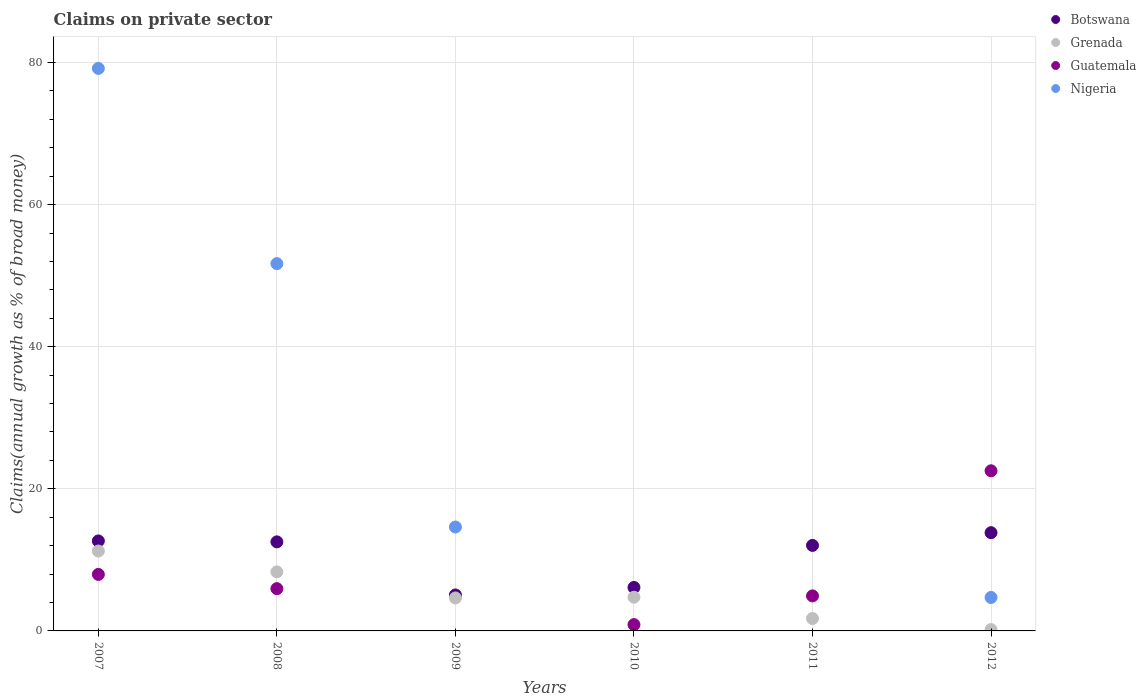What is the percentage of broad money claimed on private sector in Nigeria in 2008?
Your answer should be very brief. 51.69. Across all years, what is the maximum percentage of broad money claimed on private sector in Nigeria?
Provide a short and direct response. 79.17. Across all years, what is the minimum percentage of broad money claimed on private sector in Botswana?
Make the answer very short. 5.06. In which year was the percentage of broad money claimed on private sector in Guatemala maximum?
Offer a very short reply. 2012. What is the total percentage of broad money claimed on private sector in Botswana in the graph?
Ensure brevity in your answer.  62.25. What is the difference between the percentage of broad money claimed on private sector in Grenada in 2007 and that in 2008?
Your answer should be very brief. 2.93. What is the difference between the percentage of broad money claimed on private sector in Grenada in 2008 and the percentage of broad money claimed on private sector in Nigeria in 2012?
Give a very brief answer. 3.6. What is the average percentage of broad money claimed on private sector in Grenada per year?
Your response must be concise. 5.15. In the year 2010, what is the difference between the percentage of broad money claimed on private sector in Botswana and percentage of broad money claimed on private sector in Guatemala?
Your answer should be compact. 5.23. In how many years, is the percentage of broad money claimed on private sector in Guatemala greater than 44 %?
Ensure brevity in your answer.  0. What is the ratio of the percentage of broad money claimed on private sector in Guatemala in 2008 to that in 2012?
Offer a terse response. 0.26. Is the percentage of broad money claimed on private sector in Grenada in 2010 less than that in 2012?
Provide a short and direct response. No. What is the difference between the highest and the second highest percentage of broad money claimed on private sector in Guatemala?
Give a very brief answer. 14.58. What is the difference between the highest and the lowest percentage of broad money claimed on private sector in Guatemala?
Make the answer very short. 22.54. In how many years, is the percentage of broad money claimed on private sector in Guatemala greater than the average percentage of broad money claimed on private sector in Guatemala taken over all years?
Your answer should be very brief. 2. Is the sum of the percentage of broad money claimed on private sector in Botswana in 2011 and 2012 greater than the maximum percentage of broad money claimed on private sector in Grenada across all years?
Provide a succinct answer. Yes. Does the percentage of broad money claimed on private sector in Botswana monotonically increase over the years?
Your response must be concise. No. Is the percentage of broad money claimed on private sector in Grenada strictly less than the percentage of broad money claimed on private sector in Nigeria over the years?
Your response must be concise. No. How many years are there in the graph?
Provide a short and direct response. 6. What is the difference between two consecutive major ticks on the Y-axis?
Offer a terse response. 20. Are the values on the major ticks of Y-axis written in scientific E-notation?
Your response must be concise. No. What is the title of the graph?
Your response must be concise. Claims on private sector. What is the label or title of the X-axis?
Keep it short and to the point. Years. What is the label or title of the Y-axis?
Your answer should be compact. Claims(annual growth as % of broad money). What is the Claims(annual growth as % of broad money) in Botswana in 2007?
Provide a short and direct response. 12.67. What is the Claims(annual growth as % of broad money) of Grenada in 2007?
Your response must be concise. 11.25. What is the Claims(annual growth as % of broad money) of Guatemala in 2007?
Offer a very short reply. 7.96. What is the Claims(annual growth as % of broad money) of Nigeria in 2007?
Provide a short and direct response. 79.17. What is the Claims(annual growth as % of broad money) in Botswana in 2008?
Offer a very short reply. 12.54. What is the Claims(annual growth as % of broad money) of Grenada in 2008?
Your response must be concise. 8.31. What is the Claims(annual growth as % of broad money) in Guatemala in 2008?
Make the answer very short. 5.95. What is the Claims(annual growth as % of broad money) in Nigeria in 2008?
Give a very brief answer. 51.69. What is the Claims(annual growth as % of broad money) of Botswana in 2009?
Your answer should be compact. 5.06. What is the Claims(annual growth as % of broad money) of Grenada in 2009?
Ensure brevity in your answer.  4.64. What is the Claims(annual growth as % of broad money) in Nigeria in 2009?
Ensure brevity in your answer.  14.63. What is the Claims(annual growth as % of broad money) in Botswana in 2010?
Ensure brevity in your answer.  6.12. What is the Claims(annual growth as % of broad money) in Grenada in 2010?
Your answer should be compact. 4.75. What is the Claims(annual growth as % of broad money) of Guatemala in 2010?
Offer a terse response. 0.88. What is the Claims(annual growth as % of broad money) of Nigeria in 2010?
Keep it short and to the point. 0. What is the Claims(annual growth as % of broad money) of Botswana in 2011?
Provide a short and direct response. 12.04. What is the Claims(annual growth as % of broad money) in Grenada in 2011?
Ensure brevity in your answer.  1.75. What is the Claims(annual growth as % of broad money) of Guatemala in 2011?
Ensure brevity in your answer.  4.93. What is the Claims(annual growth as % of broad money) in Botswana in 2012?
Provide a succinct answer. 13.83. What is the Claims(annual growth as % of broad money) in Grenada in 2012?
Keep it short and to the point. 0.19. What is the Claims(annual growth as % of broad money) of Guatemala in 2012?
Your answer should be very brief. 22.54. What is the Claims(annual growth as % of broad money) of Nigeria in 2012?
Your response must be concise. 4.71. Across all years, what is the maximum Claims(annual growth as % of broad money) in Botswana?
Provide a short and direct response. 13.83. Across all years, what is the maximum Claims(annual growth as % of broad money) in Grenada?
Your answer should be very brief. 11.25. Across all years, what is the maximum Claims(annual growth as % of broad money) of Guatemala?
Give a very brief answer. 22.54. Across all years, what is the maximum Claims(annual growth as % of broad money) of Nigeria?
Offer a very short reply. 79.17. Across all years, what is the minimum Claims(annual growth as % of broad money) in Botswana?
Ensure brevity in your answer.  5.06. Across all years, what is the minimum Claims(annual growth as % of broad money) of Grenada?
Your answer should be very brief. 0.19. Across all years, what is the minimum Claims(annual growth as % of broad money) of Nigeria?
Give a very brief answer. 0. What is the total Claims(annual growth as % of broad money) in Botswana in the graph?
Make the answer very short. 62.25. What is the total Claims(annual growth as % of broad money) in Grenada in the graph?
Offer a terse response. 30.88. What is the total Claims(annual growth as % of broad money) in Guatemala in the graph?
Keep it short and to the point. 42.26. What is the total Claims(annual growth as % of broad money) of Nigeria in the graph?
Offer a very short reply. 150.2. What is the difference between the Claims(annual growth as % of broad money) of Botswana in 2007 and that in 2008?
Ensure brevity in your answer.  0.13. What is the difference between the Claims(annual growth as % of broad money) of Grenada in 2007 and that in 2008?
Ensure brevity in your answer.  2.93. What is the difference between the Claims(annual growth as % of broad money) in Guatemala in 2007 and that in 2008?
Give a very brief answer. 2.01. What is the difference between the Claims(annual growth as % of broad money) of Nigeria in 2007 and that in 2008?
Your answer should be very brief. 27.48. What is the difference between the Claims(annual growth as % of broad money) in Botswana in 2007 and that in 2009?
Ensure brevity in your answer.  7.61. What is the difference between the Claims(annual growth as % of broad money) of Grenada in 2007 and that in 2009?
Offer a very short reply. 6.6. What is the difference between the Claims(annual growth as % of broad money) in Nigeria in 2007 and that in 2009?
Keep it short and to the point. 64.55. What is the difference between the Claims(annual growth as % of broad money) of Botswana in 2007 and that in 2010?
Your answer should be very brief. 6.55. What is the difference between the Claims(annual growth as % of broad money) of Guatemala in 2007 and that in 2010?
Your response must be concise. 7.07. What is the difference between the Claims(annual growth as % of broad money) in Botswana in 2007 and that in 2011?
Offer a terse response. 0.63. What is the difference between the Claims(annual growth as % of broad money) of Grenada in 2007 and that in 2011?
Provide a succinct answer. 9.5. What is the difference between the Claims(annual growth as % of broad money) of Guatemala in 2007 and that in 2011?
Ensure brevity in your answer.  3.02. What is the difference between the Claims(annual growth as % of broad money) of Botswana in 2007 and that in 2012?
Offer a very short reply. -1.16. What is the difference between the Claims(annual growth as % of broad money) in Grenada in 2007 and that in 2012?
Provide a short and direct response. 11.06. What is the difference between the Claims(annual growth as % of broad money) in Guatemala in 2007 and that in 2012?
Offer a terse response. -14.58. What is the difference between the Claims(annual growth as % of broad money) in Nigeria in 2007 and that in 2012?
Your answer should be very brief. 74.47. What is the difference between the Claims(annual growth as % of broad money) in Botswana in 2008 and that in 2009?
Give a very brief answer. 7.47. What is the difference between the Claims(annual growth as % of broad money) of Grenada in 2008 and that in 2009?
Your response must be concise. 3.67. What is the difference between the Claims(annual growth as % of broad money) of Nigeria in 2008 and that in 2009?
Provide a short and direct response. 37.07. What is the difference between the Claims(annual growth as % of broad money) in Botswana in 2008 and that in 2010?
Give a very brief answer. 6.42. What is the difference between the Claims(annual growth as % of broad money) in Grenada in 2008 and that in 2010?
Ensure brevity in your answer.  3.57. What is the difference between the Claims(annual growth as % of broad money) in Guatemala in 2008 and that in 2010?
Give a very brief answer. 5.06. What is the difference between the Claims(annual growth as % of broad money) of Botswana in 2008 and that in 2011?
Make the answer very short. 0.5. What is the difference between the Claims(annual growth as % of broad money) in Grenada in 2008 and that in 2011?
Offer a very short reply. 6.56. What is the difference between the Claims(annual growth as % of broad money) in Guatemala in 2008 and that in 2011?
Give a very brief answer. 1.02. What is the difference between the Claims(annual growth as % of broad money) in Botswana in 2008 and that in 2012?
Keep it short and to the point. -1.29. What is the difference between the Claims(annual growth as % of broad money) of Grenada in 2008 and that in 2012?
Ensure brevity in your answer.  8.12. What is the difference between the Claims(annual growth as % of broad money) in Guatemala in 2008 and that in 2012?
Make the answer very short. -16.59. What is the difference between the Claims(annual growth as % of broad money) in Nigeria in 2008 and that in 2012?
Your answer should be compact. 46.99. What is the difference between the Claims(annual growth as % of broad money) of Botswana in 2009 and that in 2010?
Ensure brevity in your answer.  -1.06. What is the difference between the Claims(annual growth as % of broad money) of Grenada in 2009 and that in 2010?
Provide a short and direct response. -0.1. What is the difference between the Claims(annual growth as % of broad money) of Botswana in 2009 and that in 2011?
Make the answer very short. -6.97. What is the difference between the Claims(annual growth as % of broad money) of Grenada in 2009 and that in 2011?
Your answer should be compact. 2.9. What is the difference between the Claims(annual growth as % of broad money) in Botswana in 2009 and that in 2012?
Ensure brevity in your answer.  -8.77. What is the difference between the Claims(annual growth as % of broad money) in Grenada in 2009 and that in 2012?
Give a very brief answer. 4.45. What is the difference between the Claims(annual growth as % of broad money) in Nigeria in 2009 and that in 2012?
Offer a terse response. 9.92. What is the difference between the Claims(annual growth as % of broad money) of Botswana in 2010 and that in 2011?
Give a very brief answer. -5.92. What is the difference between the Claims(annual growth as % of broad money) in Grenada in 2010 and that in 2011?
Offer a terse response. 3. What is the difference between the Claims(annual growth as % of broad money) in Guatemala in 2010 and that in 2011?
Give a very brief answer. -4.05. What is the difference between the Claims(annual growth as % of broad money) in Botswana in 2010 and that in 2012?
Your response must be concise. -7.71. What is the difference between the Claims(annual growth as % of broad money) in Grenada in 2010 and that in 2012?
Your response must be concise. 4.56. What is the difference between the Claims(annual growth as % of broad money) in Guatemala in 2010 and that in 2012?
Your answer should be compact. -21.65. What is the difference between the Claims(annual growth as % of broad money) in Botswana in 2011 and that in 2012?
Your response must be concise. -1.79. What is the difference between the Claims(annual growth as % of broad money) of Grenada in 2011 and that in 2012?
Make the answer very short. 1.56. What is the difference between the Claims(annual growth as % of broad money) of Guatemala in 2011 and that in 2012?
Your response must be concise. -17.61. What is the difference between the Claims(annual growth as % of broad money) of Botswana in 2007 and the Claims(annual growth as % of broad money) of Grenada in 2008?
Provide a succinct answer. 4.36. What is the difference between the Claims(annual growth as % of broad money) of Botswana in 2007 and the Claims(annual growth as % of broad money) of Guatemala in 2008?
Your answer should be very brief. 6.72. What is the difference between the Claims(annual growth as % of broad money) in Botswana in 2007 and the Claims(annual growth as % of broad money) in Nigeria in 2008?
Offer a very short reply. -39.03. What is the difference between the Claims(annual growth as % of broad money) in Grenada in 2007 and the Claims(annual growth as % of broad money) in Guatemala in 2008?
Give a very brief answer. 5.3. What is the difference between the Claims(annual growth as % of broad money) in Grenada in 2007 and the Claims(annual growth as % of broad money) in Nigeria in 2008?
Make the answer very short. -40.45. What is the difference between the Claims(annual growth as % of broad money) in Guatemala in 2007 and the Claims(annual growth as % of broad money) in Nigeria in 2008?
Provide a succinct answer. -43.74. What is the difference between the Claims(annual growth as % of broad money) in Botswana in 2007 and the Claims(annual growth as % of broad money) in Grenada in 2009?
Make the answer very short. 8.03. What is the difference between the Claims(annual growth as % of broad money) of Botswana in 2007 and the Claims(annual growth as % of broad money) of Nigeria in 2009?
Give a very brief answer. -1.96. What is the difference between the Claims(annual growth as % of broad money) of Grenada in 2007 and the Claims(annual growth as % of broad money) of Nigeria in 2009?
Your answer should be compact. -3.38. What is the difference between the Claims(annual growth as % of broad money) of Guatemala in 2007 and the Claims(annual growth as % of broad money) of Nigeria in 2009?
Provide a succinct answer. -6.67. What is the difference between the Claims(annual growth as % of broad money) of Botswana in 2007 and the Claims(annual growth as % of broad money) of Grenada in 2010?
Your answer should be very brief. 7.92. What is the difference between the Claims(annual growth as % of broad money) of Botswana in 2007 and the Claims(annual growth as % of broad money) of Guatemala in 2010?
Provide a short and direct response. 11.78. What is the difference between the Claims(annual growth as % of broad money) in Grenada in 2007 and the Claims(annual growth as % of broad money) in Guatemala in 2010?
Offer a terse response. 10.36. What is the difference between the Claims(annual growth as % of broad money) of Botswana in 2007 and the Claims(annual growth as % of broad money) of Grenada in 2011?
Your response must be concise. 10.92. What is the difference between the Claims(annual growth as % of broad money) in Botswana in 2007 and the Claims(annual growth as % of broad money) in Guatemala in 2011?
Provide a short and direct response. 7.73. What is the difference between the Claims(annual growth as % of broad money) in Grenada in 2007 and the Claims(annual growth as % of broad money) in Guatemala in 2011?
Your answer should be compact. 6.31. What is the difference between the Claims(annual growth as % of broad money) in Botswana in 2007 and the Claims(annual growth as % of broad money) in Grenada in 2012?
Keep it short and to the point. 12.48. What is the difference between the Claims(annual growth as % of broad money) in Botswana in 2007 and the Claims(annual growth as % of broad money) in Guatemala in 2012?
Offer a very short reply. -9.87. What is the difference between the Claims(annual growth as % of broad money) of Botswana in 2007 and the Claims(annual growth as % of broad money) of Nigeria in 2012?
Keep it short and to the point. 7.96. What is the difference between the Claims(annual growth as % of broad money) of Grenada in 2007 and the Claims(annual growth as % of broad money) of Guatemala in 2012?
Offer a very short reply. -11.29. What is the difference between the Claims(annual growth as % of broad money) in Grenada in 2007 and the Claims(annual growth as % of broad money) in Nigeria in 2012?
Your answer should be compact. 6.54. What is the difference between the Claims(annual growth as % of broad money) in Guatemala in 2007 and the Claims(annual growth as % of broad money) in Nigeria in 2012?
Offer a very short reply. 3.25. What is the difference between the Claims(annual growth as % of broad money) of Botswana in 2008 and the Claims(annual growth as % of broad money) of Grenada in 2009?
Offer a very short reply. 7.89. What is the difference between the Claims(annual growth as % of broad money) in Botswana in 2008 and the Claims(annual growth as % of broad money) in Nigeria in 2009?
Provide a succinct answer. -2.09. What is the difference between the Claims(annual growth as % of broad money) of Grenada in 2008 and the Claims(annual growth as % of broad money) of Nigeria in 2009?
Give a very brief answer. -6.32. What is the difference between the Claims(annual growth as % of broad money) of Guatemala in 2008 and the Claims(annual growth as % of broad money) of Nigeria in 2009?
Ensure brevity in your answer.  -8.68. What is the difference between the Claims(annual growth as % of broad money) in Botswana in 2008 and the Claims(annual growth as % of broad money) in Grenada in 2010?
Your answer should be compact. 7.79. What is the difference between the Claims(annual growth as % of broad money) in Botswana in 2008 and the Claims(annual growth as % of broad money) in Guatemala in 2010?
Provide a short and direct response. 11.65. What is the difference between the Claims(annual growth as % of broad money) in Grenada in 2008 and the Claims(annual growth as % of broad money) in Guatemala in 2010?
Provide a short and direct response. 7.43. What is the difference between the Claims(annual growth as % of broad money) in Botswana in 2008 and the Claims(annual growth as % of broad money) in Grenada in 2011?
Your answer should be very brief. 10.79. What is the difference between the Claims(annual growth as % of broad money) of Botswana in 2008 and the Claims(annual growth as % of broad money) of Guatemala in 2011?
Give a very brief answer. 7.6. What is the difference between the Claims(annual growth as % of broad money) in Grenada in 2008 and the Claims(annual growth as % of broad money) in Guatemala in 2011?
Give a very brief answer. 3.38. What is the difference between the Claims(annual growth as % of broad money) in Botswana in 2008 and the Claims(annual growth as % of broad money) in Grenada in 2012?
Make the answer very short. 12.35. What is the difference between the Claims(annual growth as % of broad money) of Botswana in 2008 and the Claims(annual growth as % of broad money) of Guatemala in 2012?
Your response must be concise. -10. What is the difference between the Claims(annual growth as % of broad money) in Botswana in 2008 and the Claims(annual growth as % of broad money) in Nigeria in 2012?
Give a very brief answer. 7.83. What is the difference between the Claims(annual growth as % of broad money) of Grenada in 2008 and the Claims(annual growth as % of broad money) of Guatemala in 2012?
Your answer should be compact. -14.23. What is the difference between the Claims(annual growth as % of broad money) in Grenada in 2008 and the Claims(annual growth as % of broad money) in Nigeria in 2012?
Your answer should be compact. 3.6. What is the difference between the Claims(annual growth as % of broad money) in Guatemala in 2008 and the Claims(annual growth as % of broad money) in Nigeria in 2012?
Your answer should be very brief. 1.24. What is the difference between the Claims(annual growth as % of broad money) of Botswana in 2009 and the Claims(annual growth as % of broad money) of Grenada in 2010?
Provide a short and direct response. 0.32. What is the difference between the Claims(annual growth as % of broad money) of Botswana in 2009 and the Claims(annual growth as % of broad money) of Guatemala in 2010?
Give a very brief answer. 4.18. What is the difference between the Claims(annual growth as % of broad money) in Grenada in 2009 and the Claims(annual growth as % of broad money) in Guatemala in 2010?
Your answer should be very brief. 3.76. What is the difference between the Claims(annual growth as % of broad money) in Botswana in 2009 and the Claims(annual growth as % of broad money) in Grenada in 2011?
Your answer should be compact. 3.31. What is the difference between the Claims(annual growth as % of broad money) in Botswana in 2009 and the Claims(annual growth as % of broad money) in Guatemala in 2011?
Your answer should be compact. 0.13. What is the difference between the Claims(annual growth as % of broad money) of Grenada in 2009 and the Claims(annual growth as % of broad money) of Guatemala in 2011?
Keep it short and to the point. -0.29. What is the difference between the Claims(annual growth as % of broad money) of Botswana in 2009 and the Claims(annual growth as % of broad money) of Grenada in 2012?
Offer a terse response. 4.87. What is the difference between the Claims(annual growth as % of broad money) in Botswana in 2009 and the Claims(annual growth as % of broad money) in Guatemala in 2012?
Offer a terse response. -17.48. What is the difference between the Claims(annual growth as % of broad money) in Botswana in 2009 and the Claims(annual growth as % of broad money) in Nigeria in 2012?
Provide a short and direct response. 0.35. What is the difference between the Claims(annual growth as % of broad money) in Grenada in 2009 and the Claims(annual growth as % of broad money) in Guatemala in 2012?
Offer a very short reply. -17.9. What is the difference between the Claims(annual growth as % of broad money) in Grenada in 2009 and the Claims(annual growth as % of broad money) in Nigeria in 2012?
Ensure brevity in your answer.  -0.07. What is the difference between the Claims(annual growth as % of broad money) in Botswana in 2010 and the Claims(annual growth as % of broad money) in Grenada in 2011?
Offer a terse response. 4.37. What is the difference between the Claims(annual growth as % of broad money) in Botswana in 2010 and the Claims(annual growth as % of broad money) in Guatemala in 2011?
Give a very brief answer. 1.19. What is the difference between the Claims(annual growth as % of broad money) in Grenada in 2010 and the Claims(annual growth as % of broad money) in Guatemala in 2011?
Provide a short and direct response. -0.19. What is the difference between the Claims(annual growth as % of broad money) of Botswana in 2010 and the Claims(annual growth as % of broad money) of Grenada in 2012?
Your answer should be compact. 5.93. What is the difference between the Claims(annual growth as % of broad money) in Botswana in 2010 and the Claims(annual growth as % of broad money) in Guatemala in 2012?
Your answer should be compact. -16.42. What is the difference between the Claims(annual growth as % of broad money) of Botswana in 2010 and the Claims(annual growth as % of broad money) of Nigeria in 2012?
Offer a very short reply. 1.41. What is the difference between the Claims(annual growth as % of broad money) in Grenada in 2010 and the Claims(annual growth as % of broad money) in Guatemala in 2012?
Provide a succinct answer. -17.79. What is the difference between the Claims(annual growth as % of broad money) in Grenada in 2010 and the Claims(annual growth as % of broad money) in Nigeria in 2012?
Keep it short and to the point. 0.04. What is the difference between the Claims(annual growth as % of broad money) of Guatemala in 2010 and the Claims(annual growth as % of broad money) of Nigeria in 2012?
Your answer should be compact. -3.82. What is the difference between the Claims(annual growth as % of broad money) of Botswana in 2011 and the Claims(annual growth as % of broad money) of Grenada in 2012?
Give a very brief answer. 11.85. What is the difference between the Claims(annual growth as % of broad money) of Botswana in 2011 and the Claims(annual growth as % of broad money) of Guatemala in 2012?
Offer a terse response. -10.5. What is the difference between the Claims(annual growth as % of broad money) in Botswana in 2011 and the Claims(annual growth as % of broad money) in Nigeria in 2012?
Provide a succinct answer. 7.33. What is the difference between the Claims(annual growth as % of broad money) of Grenada in 2011 and the Claims(annual growth as % of broad money) of Guatemala in 2012?
Your response must be concise. -20.79. What is the difference between the Claims(annual growth as % of broad money) in Grenada in 2011 and the Claims(annual growth as % of broad money) in Nigeria in 2012?
Make the answer very short. -2.96. What is the difference between the Claims(annual growth as % of broad money) of Guatemala in 2011 and the Claims(annual growth as % of broad money) of Nigeria in 2012?
Your response must be concise. 0.22. What is the average Claims(annual growth as % of broad money) of Botswana per year?
Ensure brevity in your answer.  10.37. What is the average Claims(annual growth as % of broad money) in Grenada per year?
Ensure brevity in your answer.  5.15. What is the average Claims(annual growth as % of broad money) of Guatemala per year?
Keep it short and to the point. 7.04. What is the average Claims(annual growth as % of broad money) of Nigeria per year?
Provide a succinct answer. 25.03. In the year 2007, what is the difference between the Claims(annual growth as % of broad money) in Botswana and Claims(annual growth as % of broad money) in Grenada?
Offer a terse response. 1.42. In the year 2007, what is the difference between the Claims(annual growth as % of broad money) of Botswana and Claims(annual growth as % of broad money) of Guatemala?
Offer a very short reply. 4.71. In the year 2007, what is the difference between the Claims(annual growth as % of broad money) in Botswana and Claims(annual growth as % of broad money) in Nigeria?
Make the answer very short. -66.51. In the year 2007, what is the difference between the Claims(annual growth as % of broad money) in Grenada and Claims(annual growth as % of broad money) in Guatemala?
Your answer should be compact. 3.29. In the year 2007, what is the difference between the Claims(annual growth as % of broad money) in Grenada and Claims(annual growth as % of broad money) in Nigeria?
Your answer should be compact. -67.93. In the year 2007, what is the difference between the Claims(annual growth as % of broad money) in Guatemala and Claims(annual growth as % of broad money) in Nigeria?
Ensure brevity in your answer.  -71.22. In the year 2008, what is the difference between the Claims(annual growth as % of broad money) of Botswana and Claims(annual growth as % of broad money) of Grenada?
Your response must be concise. 4.23. In the year 2008, what is the difference between the Claims(annual growth as % of broad money) of Botswana and Claims(annual growth as % of broad money) of Guatemala?
Your answer should be compact. 6.59. In the year 2008, what is the difference between the Claims(annual growth as % of broad money) of Botswana and Claims(annual growth as % of broad money) of Nigeria?
Your answer should be compact. -39.16. In the year 2008, what is the difference between the Claims(annual growth as % of broad money) of Grenada and Claims(annual growth as % of broad money) of Guatemala?
Your answer should be compact. 2.36. In the year 2008, what is the difference between the Claims(annual growth as % of broad money) of Grenada and Claims(annual growth as % of broad money) of Nigeria?
Your answer should be compact. -43.38. In the year 2008, what is the difference between the Claims(annual growth as % of broad money) in Guatemala and Claims(annual growth as % of broad money) in Nigeria?
Ensure brevity in your answer.  -45.75. In the year 2009, what is the difference between the Claims(annual growth as % of broad money) in Botswana and Claims(annual growth as % of broad money) in Grenada?
Provide a succinct answer. 0.42. In the year 2009, what is the difference between the Claims(annual growth as % of broad money) of Botswana and Claims(annual growth as % of broad money) of Nigeria?
Your response must be concise. -9.57. In the year 2009, what is the difference between the Claims(annual growth as % of broad money) of Grenada and Claims(annual growth as % of broad money) of Nigeria?
Provide a short and direct response. -9.98. In the year 2010, what is the difference between the Claims(annual growth as % of broad money) of Botswana and Claims(annual growth as % of broad money) of Grenada?
Your response must be concise. 1.37. In the year 2010, what is the difference between the Claims(annual growth as % of broad money) of Botswana and Claims(annual growth as % of broad money) of Guatemala?
Make the answer very short. 5.23. In the year 2010, what is the difference between the Claims(annual growth as % of broad money) of Grenada and Claims(annual growth as % of broad money) of Guatemala?
Make the answer very short. 3.86. In the year 2011, what is the difference between the Claims(annual growth as % of broad money) in Botswana and Claims(annual growth as % of broad money) in Grenada?
Provide a succinct answer. 10.29. In the year 2011, what is the difference between the Claims(annual growth as % of broad money) of Botswana and Claims(annual growth as % of broad money) of Guatemala?
Offer a very short reply. 7.1. In the year 2011, what is the difference between the Claims(annual growth as % of broad money) in Grenada and Claims(annual growth as % of broad money) in Guatemala?
Ensure brevity in your answer.  -3.19. In the year 2012, what is the difference between the Claims(annual growth as % of broad money) of Botswana and Claims(annual growth as % of broad money) of Grenada?
Keep it short and to the point. 13.64. In the year 2012, what is the difference between the Claims(annual growth as % of broad money) in Botswana and Claims(annual growth as % of broad money) in Guatemala?
Give a very brief answer. -8.71. In the year 2012, what is the difference between the Claims(annual growth as % of broad money) of Botswana and Claims(annual growth as % of broad money) of Nigeria?
Keep it short and to the point. 9.12. In the year 2012, what is the difference between the Claims(annual growth as % of broad money) in Grenada and Claims(annual growth as % of broad money) in Guatemala?
Your response must be concise. -22.35. In the year 2012, what is the difference between the Claims(annual growth as % of broad money) in Grenada and Claims(annual growth as % of broad money) in Nigeria?
Offer a very short reply. -4.52. In the year 2012, what is the difference between the Claims(annual growth as % of broad money) of Guatemala and Claims(annual growth as % of broad money) of Nigeria?
Offer a terse response. 17.83. What is the ratio of the Claims(annual growth as % of broad money) in Botswana in 2007 to that in 2008?
Provide a short and direct response. 1.01. What is the ratio of the Claims(annual growth as % of broad money) of Grenada in 2007 to that in 2008?
Make the answer very short. 1.35. What is the ratio of the Claims(annual growth as % of broad money) of Guatemala in 2007 to that in 2008?
Give a very brief answer. 1.34. What is the ratio of the Claims(annual growth as % of broad money) in Nigeria in 2007 to that in 2008?
Offer a very short reply. 1.53. What is the ratio of the Claims(annual growth as % of broad money) in Botswana in 2007 to that in 2009?
Ensure brevity in your answer.  2.5. What is the ratio of the Claims(annual growth as % of broad money) of Grenada in 2007 to that in 2009?
Your response must be concise. 2.42. What is the ratio of the Claims(annual growth as % of broad money) in Nigeria in 2007 to that in 2009?
Provide a short and direct response. 5.41. What is the ratio of the Claims(annual growth as % of broad money) in Botswana in 2007 to that in 2010?
Ensure brevity in your answer.  2.07. What is the ratio of the Claims(annual growth as % of broad money) in Grenada in 2007 to that in 2010?
Make the answer very short. 2.37. What is the ratio of the Claims(annual growth as % of broad money) of Guatemala in 2007 to that in 2010?
Keep it short and to the point. 8.99. What is the ratio of the Claims(annual growth as % of broad money) of Botswana in 2007 to that in 2011?
Offer a very short reply. 1.05. What is the ratio of the Claims(annual growth as % of broad money) in Grenada in 2007 to that in 2011?
Make the answer very short. 6.44. What is the ratio of the Claims(annual growth as % of broad money) in Guatemala in 2007 to that in 2011?
Provide a succinct answer. 1.61. What is the ratio of the Claims(annual growth as % of broad money) in Botswana in 2007 to that in 2012?
Offer a very short reply. 0.92. What is the ratio of the Claims(annual growth as % of broad money) of Grenada in 2007 to that in 2012?
Provide a succinct answer. 59.76. What is the ratio of the Claims(annual growth as % of broad money) of Guatemala in 2007 to that in 2012?
Provide a succinct answer. 0.35. What is the ratio of the Claims(annual growth as % of broad money) of Nigeria in 2007 to that in 2012?
Offer a very short reply. 16.82. What is the ratio of the Claims(annual growth as % of broad money) in Botswana in 2008 to that in 2009?
Your answer should be very brief. 2.48. What is the ratio of the Claims(annual growth as % of broad money) of Grenada in 2008 to that in 2009?
Keep it short and to the point. 1.79. What is the ratio of the Claims(annual growth as % of broad money) of Nigeria in 2008 to that in 2009?
Offer a terse response. 3.53. What is the ratio of the Claims(annual growth as % of broad money) in Botswana in 2008 to that in 2010?
Give a very brief answer. 2.05. What is the ratio of the Claims(annual growth as % of broad money) in Grenada in 2008 to that in 2010?
Keep it short and to the point. 1.75. What is the ratio of the Claims(annual growth as % of broad money) in Guatemala in 2008 to that in 2010?
Provide a succinct answer. 6.72. What is the ratio of the Claims(annual growth as % of broad money) of Botswana in 2008 to that in 2011?
Your answer should be compact. 1.04. What is the ratio of the Claims(annual growth as % of broad money) of Grenada in 2008 to that in 2011?
Provide a short and direct response. 4.76. What is the ratio of the Claims(annual growth as % of broad money) in Guatemala in 2008 to that in 2011?
Offer a very short reply. 1.21. What is the ratio of the Claims(annual growth as % of broad money) in Botswana in 2008 to that in 2012?
Make the answer very short. 0.91. What is the ratio of the Claims(annual growth as % of broad money) of Grenada in 2008 to that in 2012?
Offer a terse response. 44.16. What is the ratio of the Claims(annual growth as % of broad money) in Guatemala in 2008 to that in 2012?
Your answer should be very brief. 0.26. What is the ratio of the Claims(annual growth as % of broad money) of Nigeria in 2008 to that in 2012?
Ensure brevity in your answer.  10.98. What is the ratio of the Claims(annual growth as % of broad money) in Botswana in 2009 to that in 2010?
Your answer should be compact. 0.83. What is the ratio of the Claims(annual growth as % of broad money) in Grenada in 2009 to that in 2010?
Your answer should be very brief. 0.98. What is the ratio of the Claims(annual growth as % of broad money) in Botswana in 2009 to that in 2011?
Offer a very short reply. 0.42. What is the ratio of the Claims(annual growth as % of broad money) in Grenada in 2009 to that in 2011?
Your answer should be compact. 2.66. What is the ratio of the Claims(annual growth as % of broad money) in Botswana in 2009 to that in 2012?
Your answer should be very brief. 0.37. What is the ratio of the Claims(annual growth as % of broad money) of Grenada in 2009 to that in 2012?
Provide a succinct answer. 24.67. What is the ratio of the Claims(annual growth as % of broad money) in Nigeria in 2009 to that in 2012?
Ensure brevity in your answer.  3.11. What is the ratio of the Claims(annual growth as % of broad money) of Botswana in 2010 to that in 2011?
Provide a succinct answer. 0.51. What is the ratio of the Claims(annual growth as % of broad money) of Grenada in 2010 to that in 2011?
Provide a succinct answer. 2.72. What is the ratio of the Claims(annual growth as % of broad money) of Guatemala in 2010 to that in 2011?
Provide a succinct answer. 0.18. What is the ratio of the Claims(annual growth as % of broad money) of Botswana in 2010 to that in 2012?
Provide a short and direct response. 0.44. What is the ratio of the Claims(annual growth as % of broad money) of Grenada in 2010 to that in 2012?
Keep it short and to the point. 25.22. What is the ratio of the Claims(annual growth as % of broad money) in Guatemala in 2010 to that in 2012?
Ensure brevity in your answer.  0.04. What is the ratio of the Claims(annual growth as % of broad money) in Botswana in 2011 to that in 2012?
Your answer should be very brief. 0.87. What is the ratio of the Claims(annual growth as % of broad money) of Grenada in 2011 to that in 2012?
Keep it short and to the point. 9.28. What is the ratio of the Claims(annual growth as % of broad money) of Guatemala in 2011 to that in 2012?
Provide a short and direct response. 0.22. What is the difference between the highest and the second highest Claims(annual growth as % of broad money) of Botswana?
Make the answer very short. 1.16. What is the difference between the highest and the second highest Claims(annual growth as % of broad money) in Grenada?
Make the answer very short. 2.93. What is the difference between the highest and the second highest Claims(annual growth as % of broad money) of Guatemala?
Provide a short and direct response. 14.58. What is the difference between the highest and the second highest Claims(annual growth as % of broad money) in Nigeria?
Offer a terse response. 27.48. What is the difference between the highest and the lowest Claims(annual growth as % of broad money) of Botswana?
Provide a short and direct response. 8.77. What is the difference between the highest and the lowest Claims(annual growth as % of broad money) of Grenada?
Offer a terse response. 11.06. What is the difference between the highest and the lowest Claims(annual growth as % of broad money) in Guatemala?
Offer a very short reply. 22.54. What is the difference between the highest and the lowest Claims(annual growth as % of broad money) in Nigeria?
Provide a short and direct response. 79.17. 